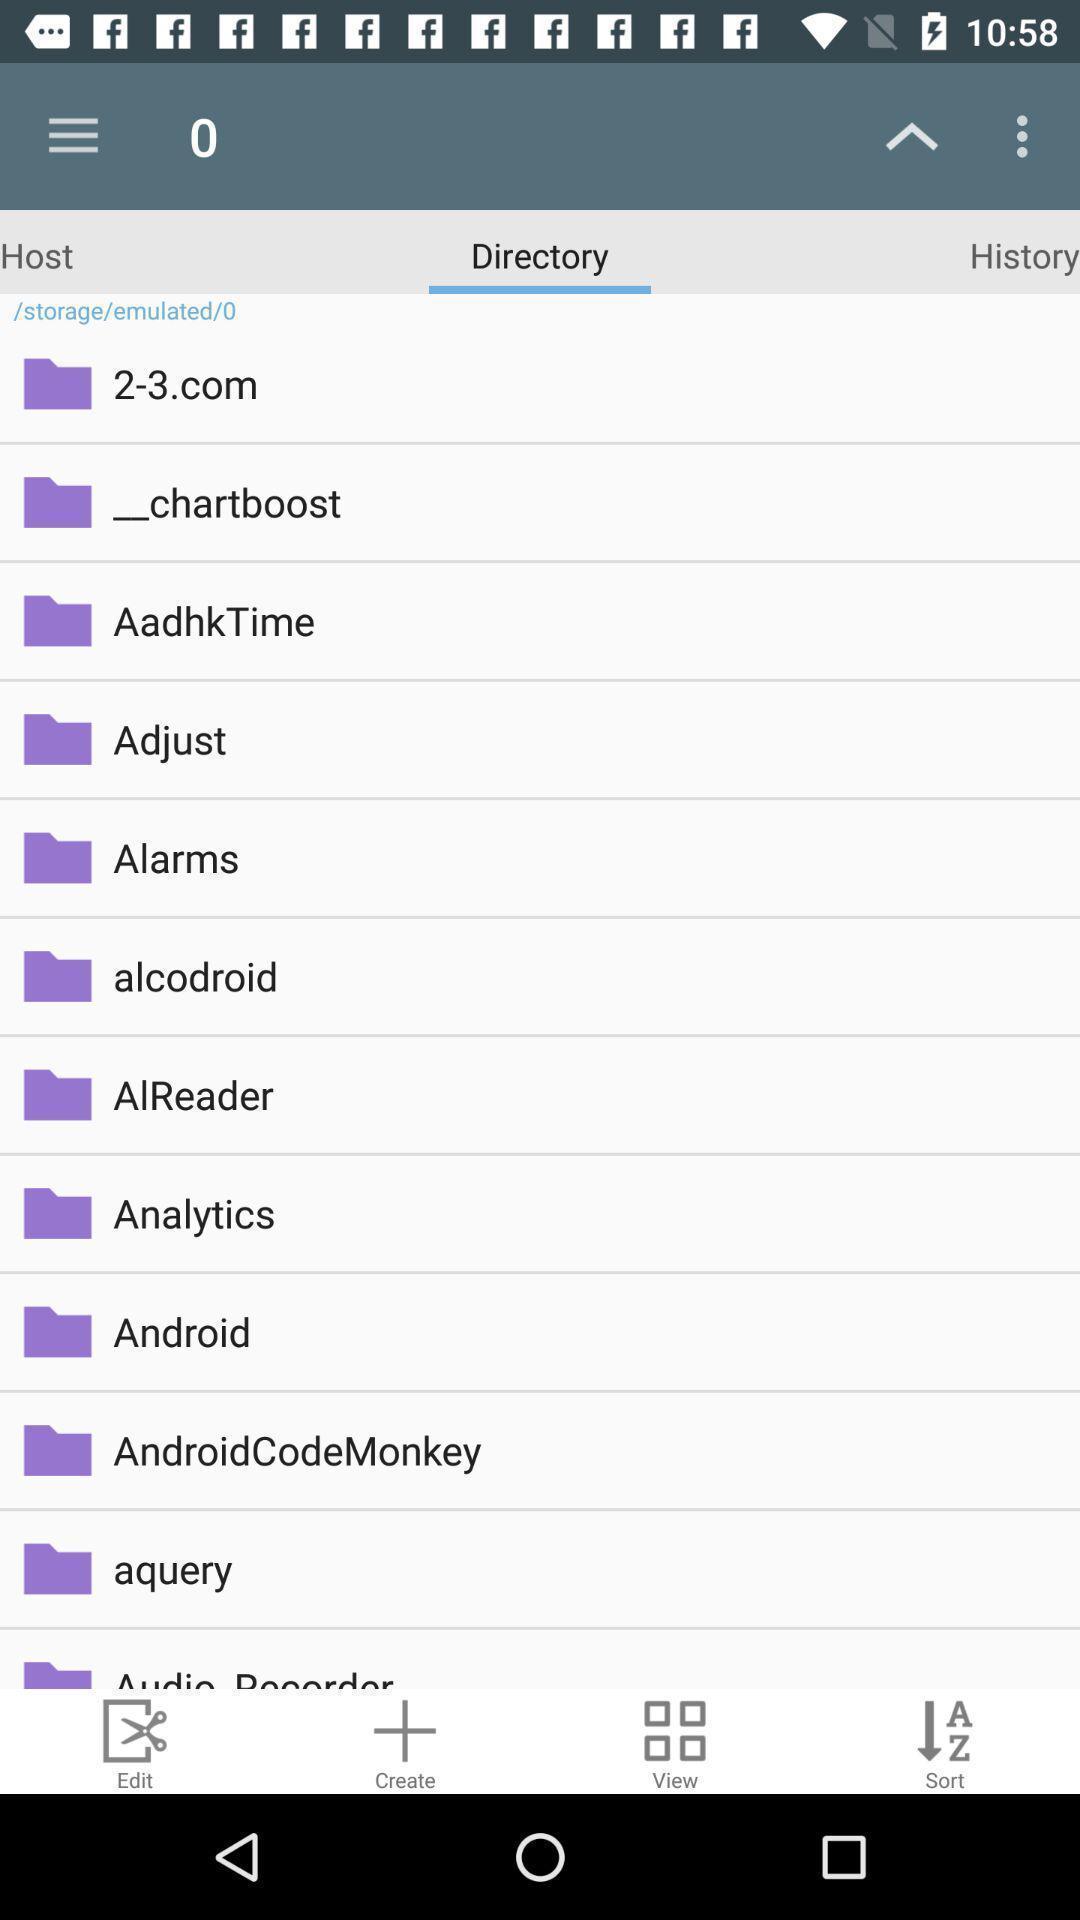Describe this image in words. Page displaying the multiple options. 